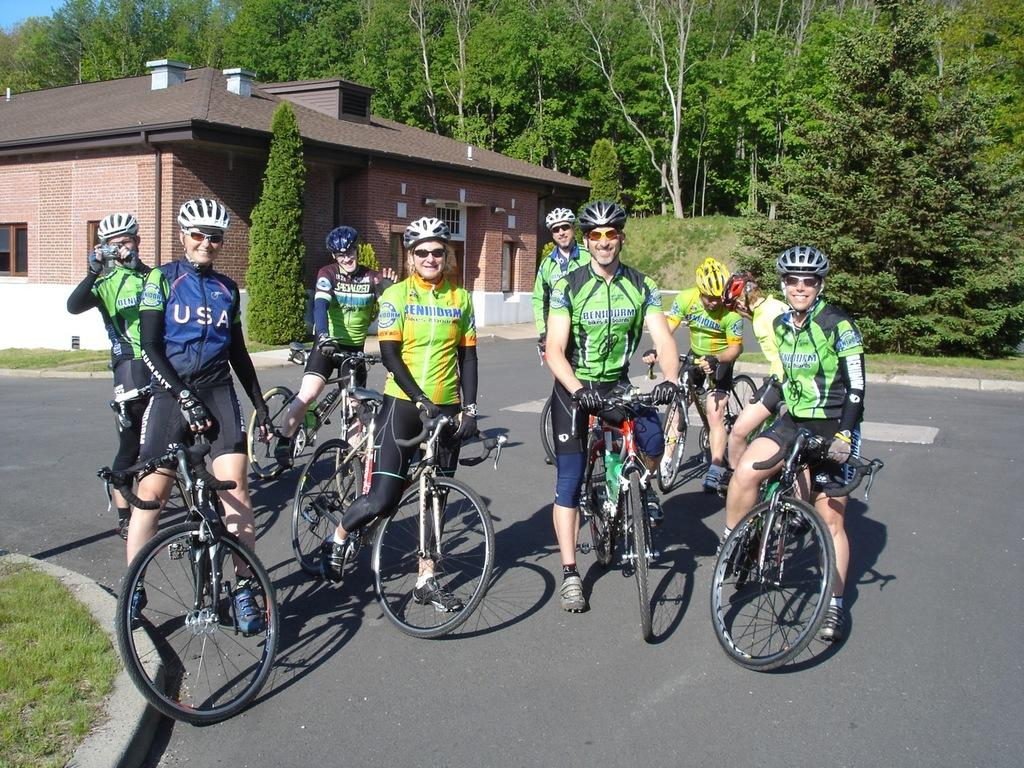How many people are in the image? There are people in the image, but the exact number is not specified. What protective gear are the people wearing? The people are wearing helmets and glasses. What type of footwear are the people wearing? The people are wearing shoes. What activity are the people engaged in? The people are riding bicycles. Where are the bicycles located? The bicycles are on the road. What can be seen in the background of the image? There is grass, a house, and trees in the background of the image. What type of honey is being harvested from the donkey in the image? There is no donkey or honey present in the image. What is the height of the people in the image? The height of the people in the image is not specified. 